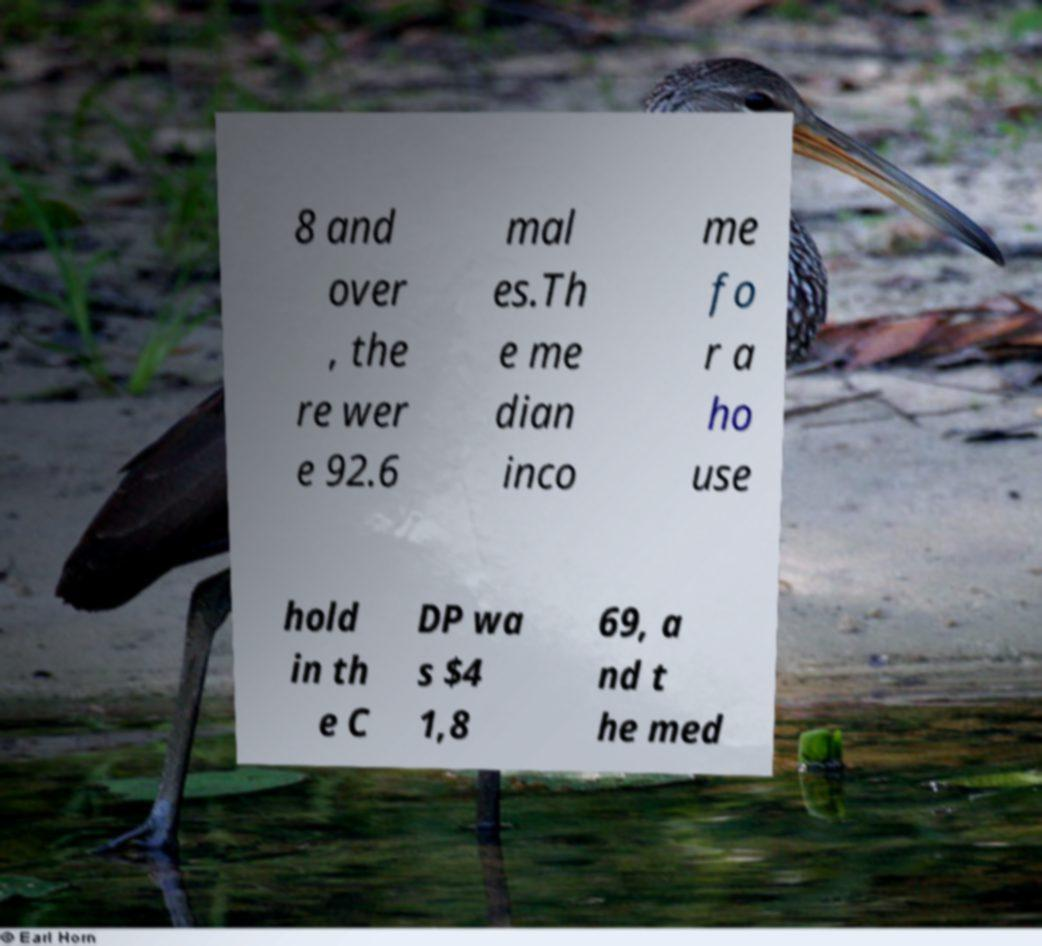There's text embedded in this image that I need extracted. Can you transcribe it verbatim? 8 and over , the re wer e 92.6 mal es.Th e me dian inco me fo r a ho use hold in th e C DP wa s $4 1,8 69, a nd t he med 